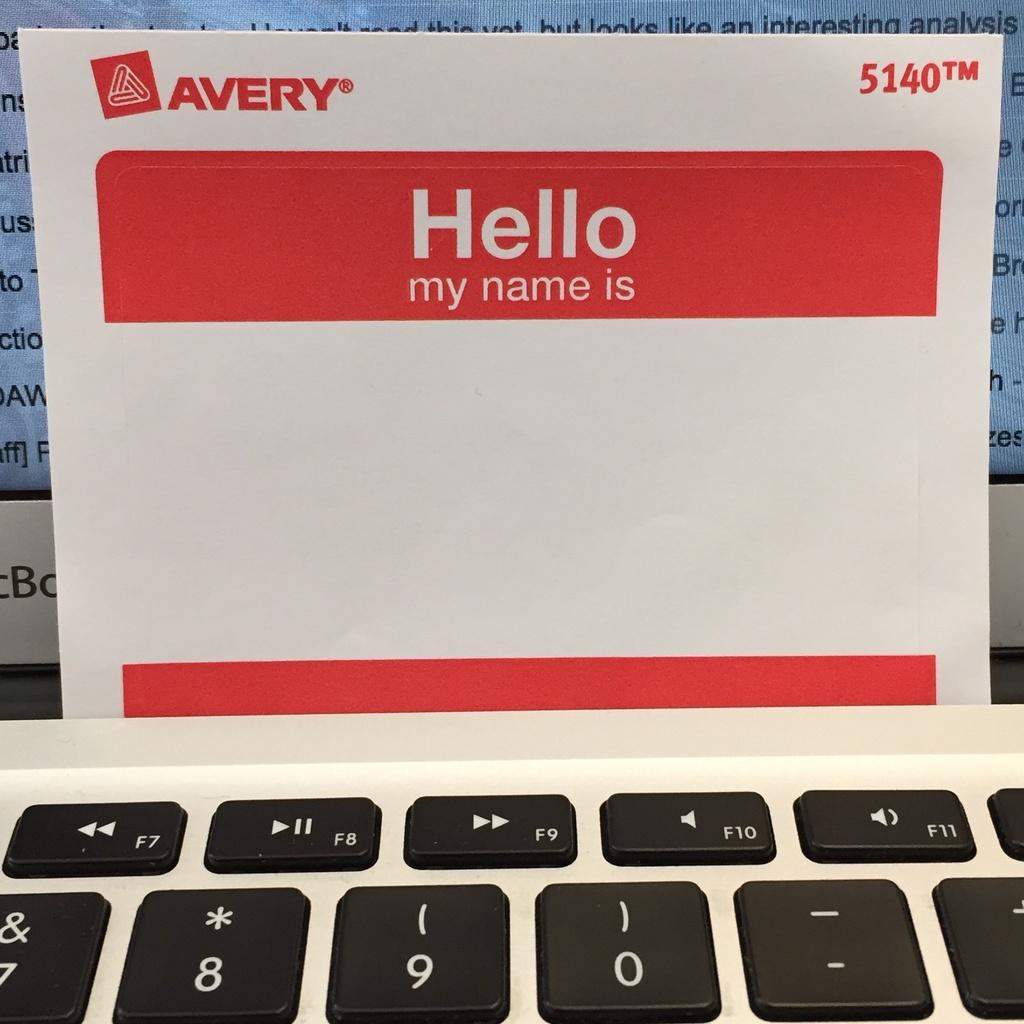<image>
Summarize the visual content of the image. a white sheet of paper that says 'hello my name is' on it 